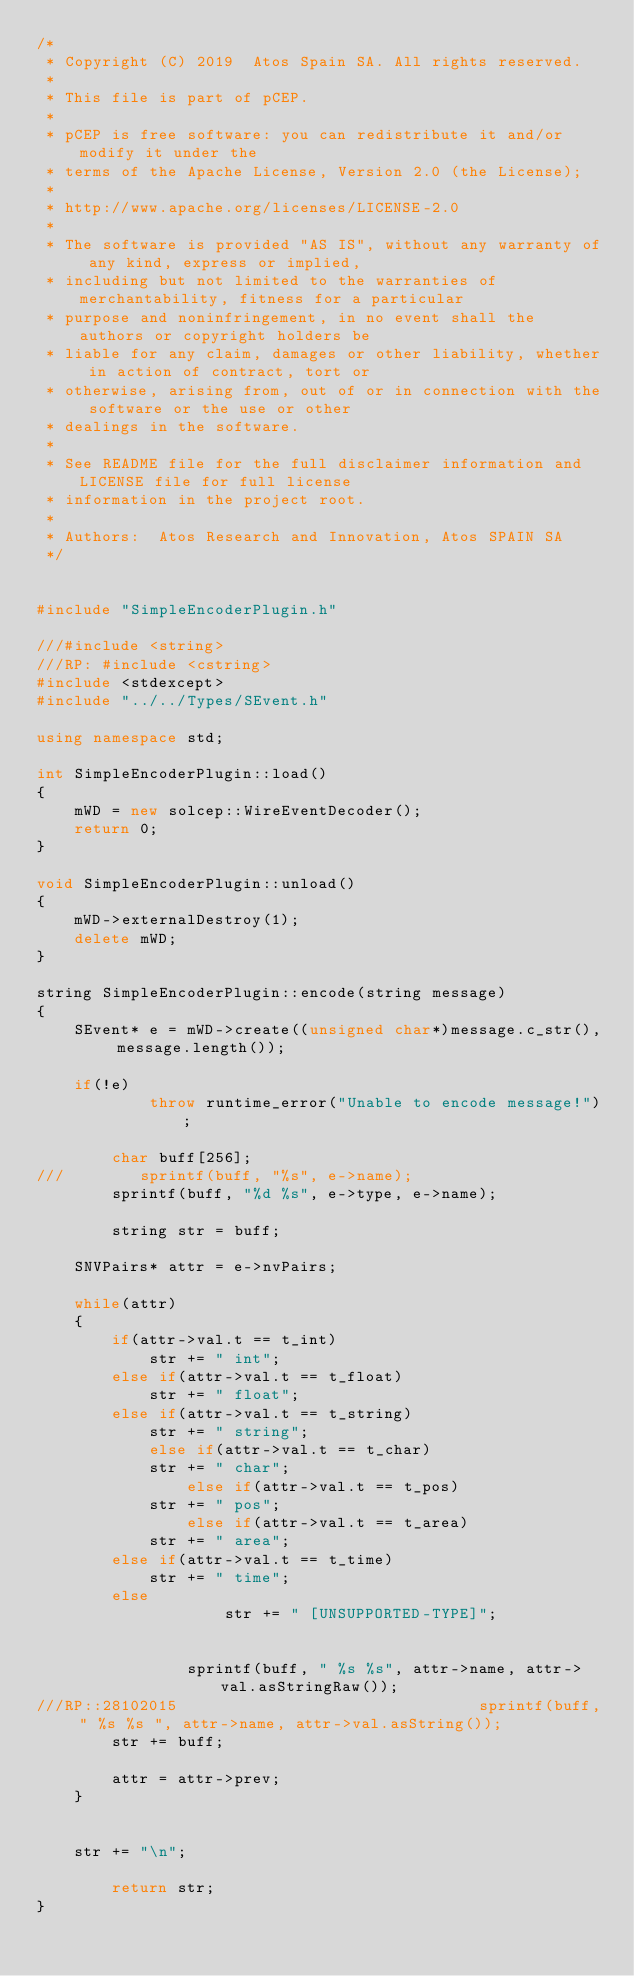<code> <loc_0><loc_0><loc_500><loc_500><_C++_>/*
 * Copyright (C) 2019  Atos Spain SA. All rights reserved.
 *
 * This file is part of pCEP.
 *
 * pCEP is free software: you can redistribute it and/or modify it under the
 * terms of the Apache License, Version 2.0 (the License);
 *
 * http://www.apache.org/licenses/LICENSE-2.0
 *
 * The software is provided "AS IS", without any warranty of any kind, express or implied,
 * including but not limited to the warranties of merchantability, fitness for a particular
 * purpose and noninfringement, in no event shall the authors or copyright holders be
 * liable for any claim, damages or other liability, whether in action of contract, tort or
 * otherwise, arising from, out of or in connection with the software or the use or other
 * dealings in the software.
 *
 * See README file for the full disclaimer information and LICENSE file for full license
 * information in the project root.
 *
 * Authors:  Atos Research and Innovation, Atos SPAIN SA
 */


#include "SimpleEncoderPlugin.h"

///#include <string>
///RP: #include <cstring>
#include <stdexcept>
#include "../../Types/SEvent.h"

using namespace std;

int SimpleEncoderPlugin::load() 
{ 
	mWD = new solcep::WireEventDecoder();
	return 0;
}

void SimpleEncoderPlugin::unload()
{
    mWD->externalDestroy(1);
    delete mWD;
}

string SimpleEncoderPlugin::encode(string message)
{
	SEvent* e = mWD->create((unsigned char*)message.c_str(), message.length());

	if(!e)
            throw runtime_error("Unable to encode message!");

        char buff[256];
///        sprintf(buff, "%s", e->name);
        sprintf(buff, "%d %s", e->type, e->name); 
	
        string str = buff;
        
	SNVPairs* attr = e->nvPairs;
	
	while(attr)
	{
		if(attr->val.t == t_int)
			str += " int";
		else if(attr->val.t == t_float)
			str += " float";
		else if(attr->val.t == t_string)
			str += " string";
        	else if(attr->val.t == t_char)
			str += " char";
                else if(attr->val.t == t_pos)
			str += " pos";
                else if(attr->val.t == t_area)
			str += " area";
		else if(attr->val.t == t_time)
			str += " time";
		else
                    str += " [UNSUPPORTED-TYPE]";

		
                sprintf(buff, " %s %s", attr->name, attr->val.asStringRaw());
///RP::28102015                                sprintf(buff, " %s %s ", attr->name, attr->val.asString());
		str += buff;

		attr = attr->prev;
	}
	
	
	str += "\n";
        
        return str;
}






</code> 